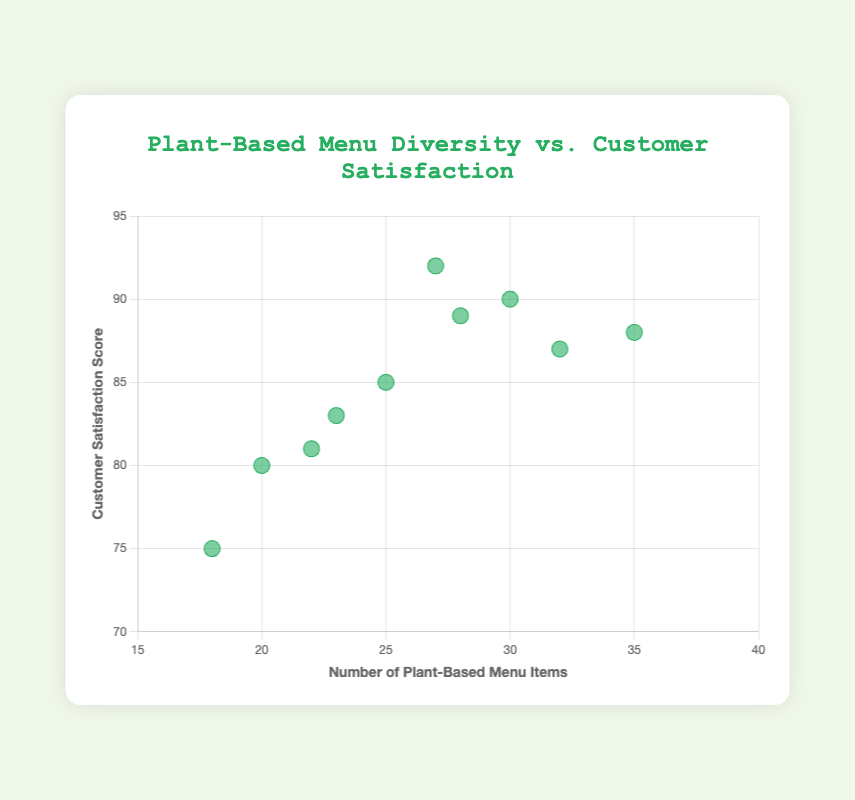What's the title of the scatter plot? The title is displayed at the top of the scatter plot and usually the largest text in the figure. In this scatter plot, it reads "Plant-Based Menu Diversity vs. Customer Satisfaction".
Answer: Plant-Based Menu Diversity vs. Customer Satisfaction How many data points are plotted in the scatter plot? The data set includes a list of 10 restaurants, each represented by a single point. Counting these, we get 10 points on the scatter plot.
Answer: 10 What is the range of customer satisfaction scores shown on the y-axis? The y-axis represents customer satisfaction scores, with the range extending from 70 to 95 according to the figure's axes.
Answer: 70 to 95 Which restaurant has the highest customer satisfaction score? By identifying the highest point on the y-axis, we find that "Plant Power" has a customer satisfaction score of 92, which is the highest.
Answer: Plant Power What's the highest number of plant-based menu items offered by a restaurant, and what is its corresponding customer satisfaction score? The restaurant with the highest number of plant-based menu items is "Leafy Greens" with 35 items. Its corresponding customer satisfaction score, seen from the point at (35, 88), is 88.
Answer: Leafy Greens, 88 Which restaurant has the lowest number of plant-based menu items, and what is its corresponding customer satisfaction score? The point with the lowest x-value represents "Veggie Haven" with 18 plant-based menu items. Its customer satisfaction score, observed from the point at (18, 75), is 75.
Answer: Veggie Haven, 75 What's the average customer satisfaction score across all restaurants? Adding all customer satisfaction scores (85+90+80+88+75+92+87+83+89+81) gives 850. Dividing this by the number of restaurants (10) yields the average score.
Answer: 85 Which two restaurants have the closest customer satisfaction scores? By comparing all scores, "Green Cuisine" (85) and "Pure Vegan" (83) have the smallest difference of 2 points.
Answer: Green Cuisine and Pure Vegan Do restaurants with more than 30 plant-based menu items tend to have higher satisfaction scores? Observing points with x-values greater than 30, we see "Earth Bistro" (90), "Leafy Greens" (88), and "Garden Fresh" (87), all with high satisfaction scores.
Answer: Yes Is there a clear positive trend between plant-based menu diversity and customer satisfaction? Analyzing the scatter plot's overall pattern, there is a general, though not perfect, positive trend where more menu items often correspond with higher satisfaction scores.
Answer: Yes 